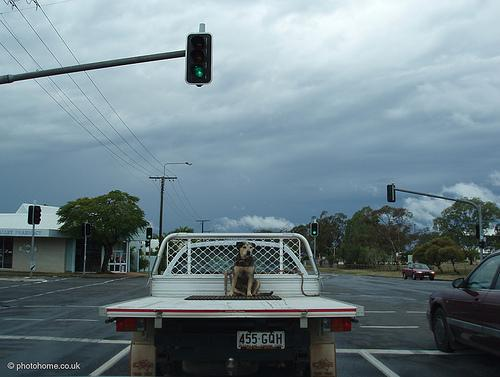Identify two objects in the image and their interaction. The red car with headlights on is stopped at a traffic light with a green signal, waiting to proceed through the intersection. Provide a brief and accurate description of the scene in the image. A dog is sitting in the back of a flatbed truck, with a red car stopped at a green traffic light, in front of white stripes on the road and trees on the side. For the complex reasoning task, speculate on what might happen in the next few moments based on the information provided in the image. In the next few moments, the red car with headlights on may proceed through the intersection, since the traffic light is green, while the dog may continue to sit or move around in the back of the flatbed truck. In your opinion, does the image have a positive, negative or neutral sentiment? The image has a neutral sentiment, as it shows a common traffic scene without any significant positive or negative elements. 